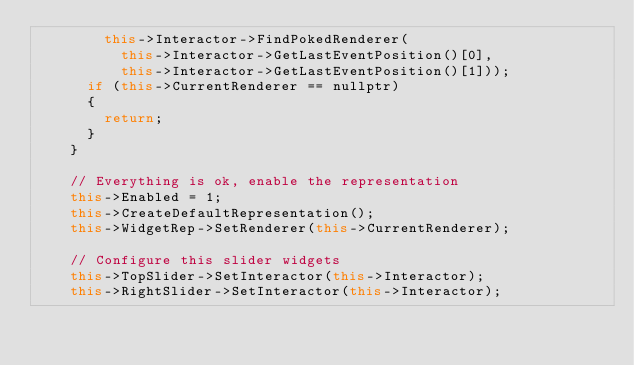<code> <loc_0><loc_0><loc_500><loc_500><_C++_>        this->Interactor->FindPokedRenderer(
          this->Interactor->GetLastEventPosition()[0],
          this->Interactor->GetLastEventPosition()[1]));
      if (this->CurrentRenderer == nullptr)
      {
        return;
      }
    }

    // Everything is ok, enable the representation
    this->Enabled = 1;
    this->CreateDefaultRepresentation();
    this->WidgetRep->SetRenderer(this->CurrentRenderer);

    // Configure this slider widgets
    this->TopSlider->SetInteractor(this->Interactor);
    this->RightSlider->SetInteractor(this->Interactor);</code> 